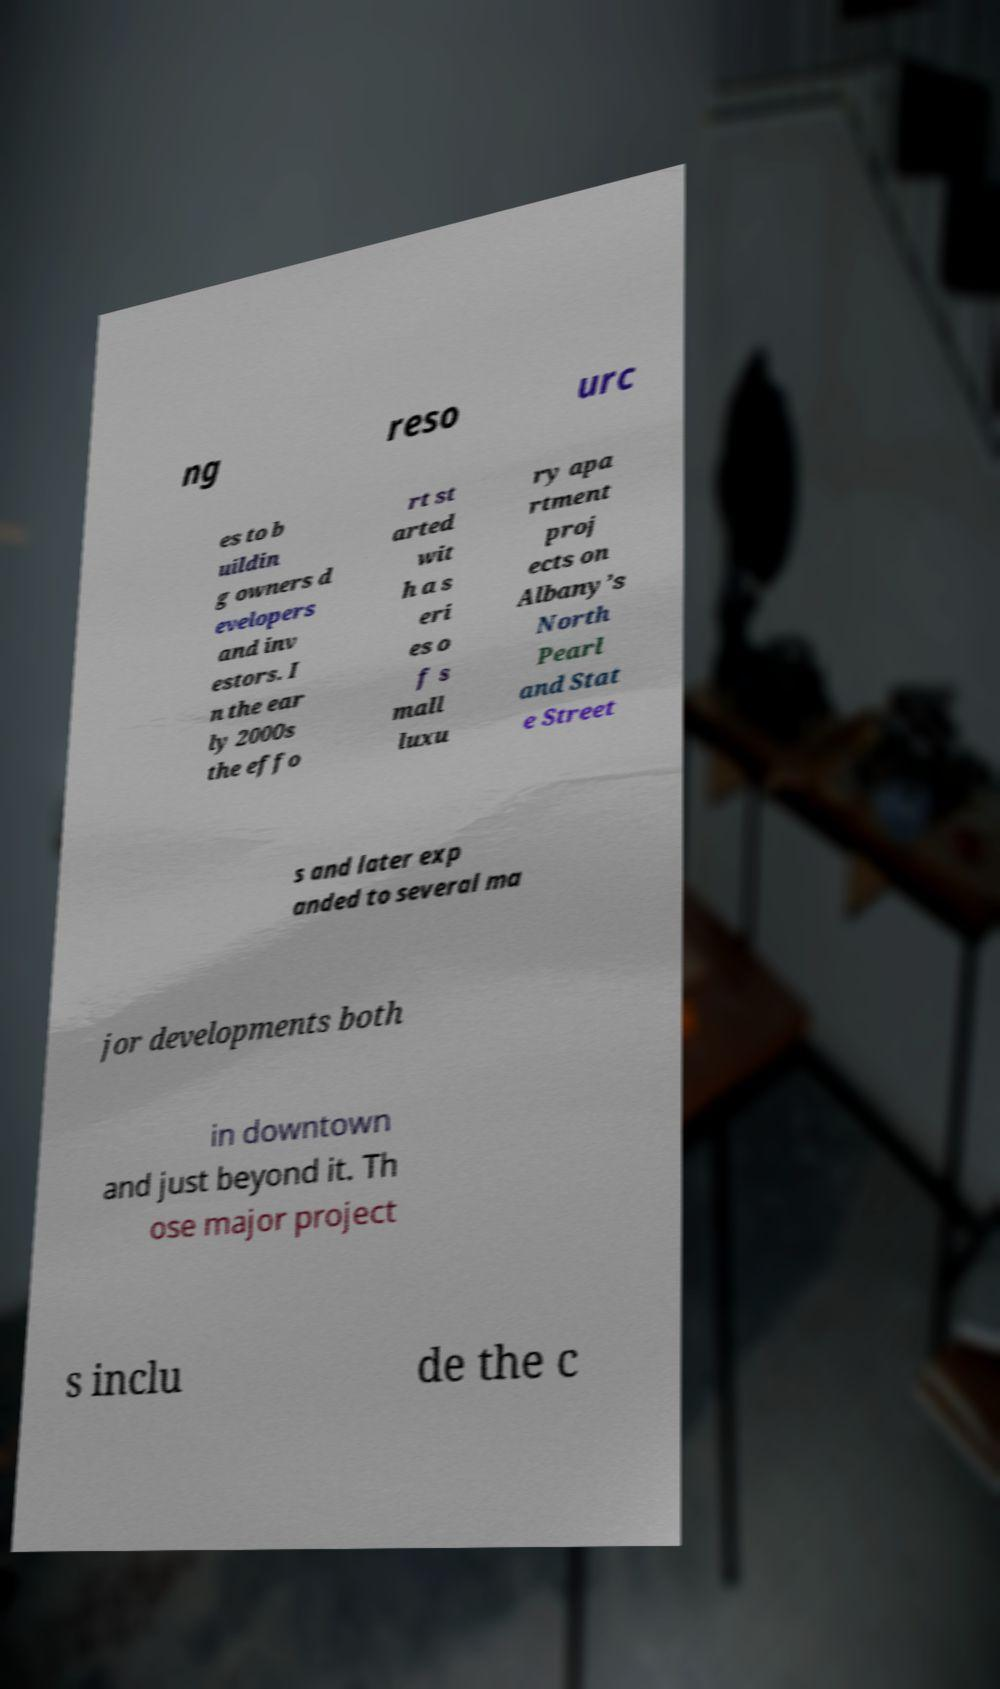For documentation purposes, I need the text within this image transcribed. Could you provide that? ng reso urc es to b uildin g owners d evelopers and inv estors. I n the ear ly 2000s the effo rt st arted wit h a s eri es o f s mall luxu ry apa rtment proj ects on Albany’s North Pearl and Stat e Street s and later exp anded to several ma jor developments both in downtown and just beyond it. Th ose major project s inclu de the c 